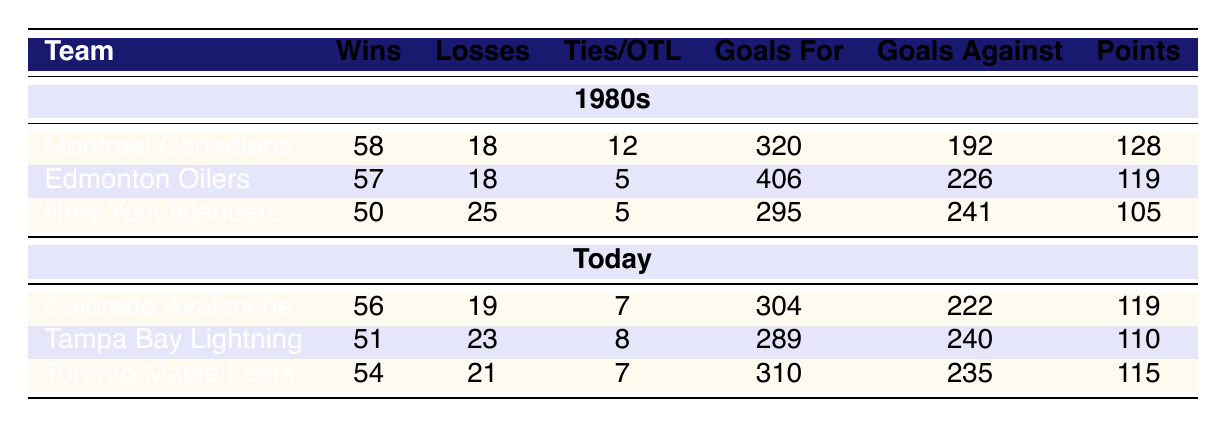What team had the highest number of wins in the 1980s? From the table, we can see that the Montreal Canadiens had 58 wins, which is the highest among all teams listed from the 1980s.
Answer: Montreal Canadiens How many points did the Edmonton Oilers earn in total? The table indicates that the Edmonton Oilers accumulated 119 points during the 1980s, as shown in the points column.
Answer: 119 Did any team today have more goals for than the Montreal Canadiens did in the 1980s? The Montreal Canadiens scored 320 goals in the 1980s. Comparing this with today's teams, the Colorado Avalanche scored 304 goals, the Tampa Bay Lightning scored 289 goals, and the Toronto Maple Leafs scored 310 goals — all of which are less than 320. Thus, no team today scored more goals than the Canadiens.
Answer: No What is the difference in points between the highest-scoring team today and the highest-scoring team in the 1980s? The highest-scoring team in the 1980s was the Edmonton Oilers with 119 points, and the highest-scoring team today is the Colorado Avalanche with also 119 points. The difference is 119 - 119 = 0.
Answer: 0 Which team had the highest goals against in the 1980s, and what was the number? By looking at the goals against column, the New York Islanders allowed 241 goals against, which is the highest among the teams of the 1980s.
Answer: New York Islanders, 241 How many total losses were recorded by the teams today compared to the teams in the 1980s? To find the total losses for the 1980s teams: 18 + 18 + 25 = 61. For today, the total losses are: 19 + 23 + 21 = 63. Therefore, teams today had 63 losses compared to 61 in the 1980s.
Answer: 63 Which team today scored the least goals for, and how many was that? From the table, the Tampa Bay Lightning scored 289 goals for, which is the smallest number among the listed teams today.
Answer: Tampa Bay Lightning, 289 What is the average number of wins for the three teams in the 1980s? To calculate the average wins: (58 + 57 + 50) / 3 = 165 / 3 = 55. Thus, the average number of wins for the three teams in the 1980s is 55.
Answer: 55 Which team's points today were the closest to the New York Islanders' points from the 1980s? The New York Islanders had 105 points. The team with the closest points today is the Tampa Bay Lightning, who secured 110 points, which is 5 points higher than the Islanders.
Answer: Tampa Bay Lightning, 110 